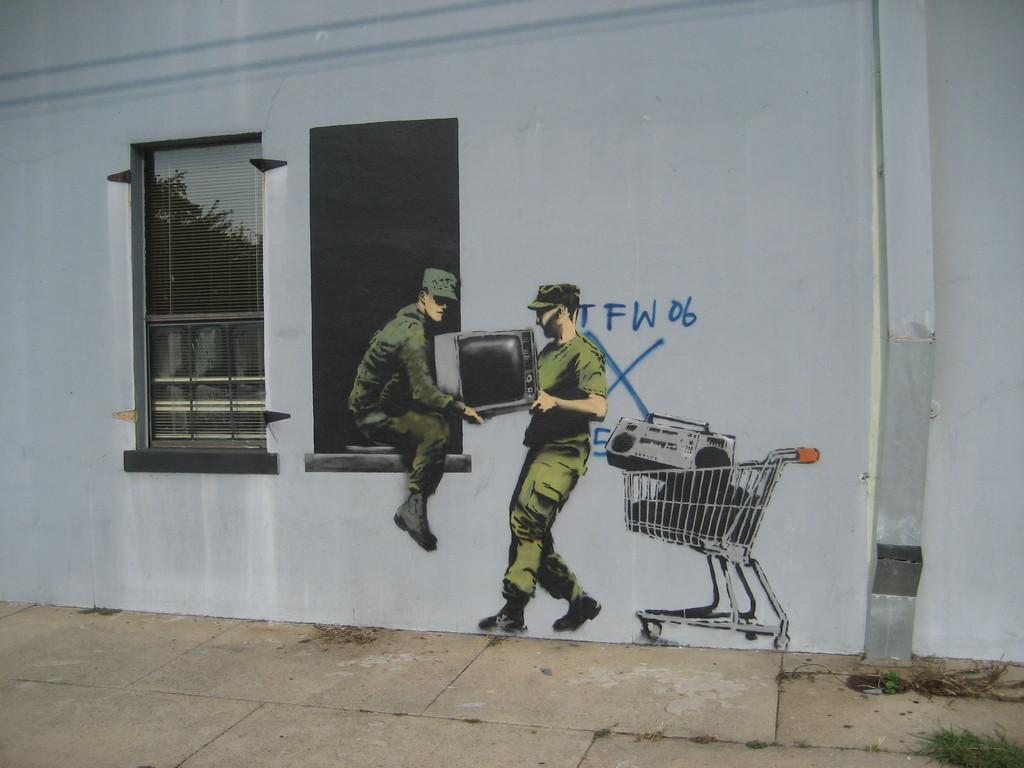Could you give a brief overview of what you see in this image? Here two person are holding television, here in the trolley there is tape recorder, here there is wall, this is window. 